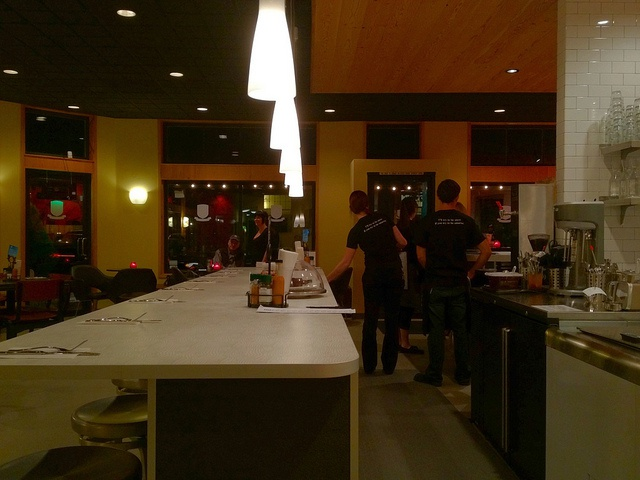Describe the objects in this image and their specific colors. I can see dining table in black, gray, and olive tones, people in black, maroon, and gray tones, people in black, maroon, and gray tones, oven in black, olive, and gray tones, and chair in black and darkgreen tones in this image. 